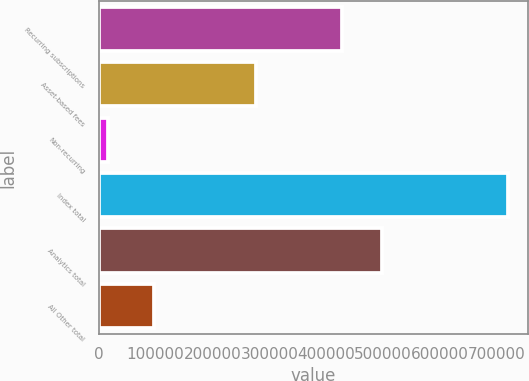Convert chart. <chart><loc_0><loc_0><loc_500><loc_500><bar_chart><fcel>Recurring subscriptions<fcel>Asset-based fees<fcel>Non-recurring<fcel>Index total<fcel>Analytics total<fcel>All Other total<nl><fcel>427289<fcel>276092<fcel>15578<fcel>718959<fcel>497627<fcel>96944<nl></chart> 